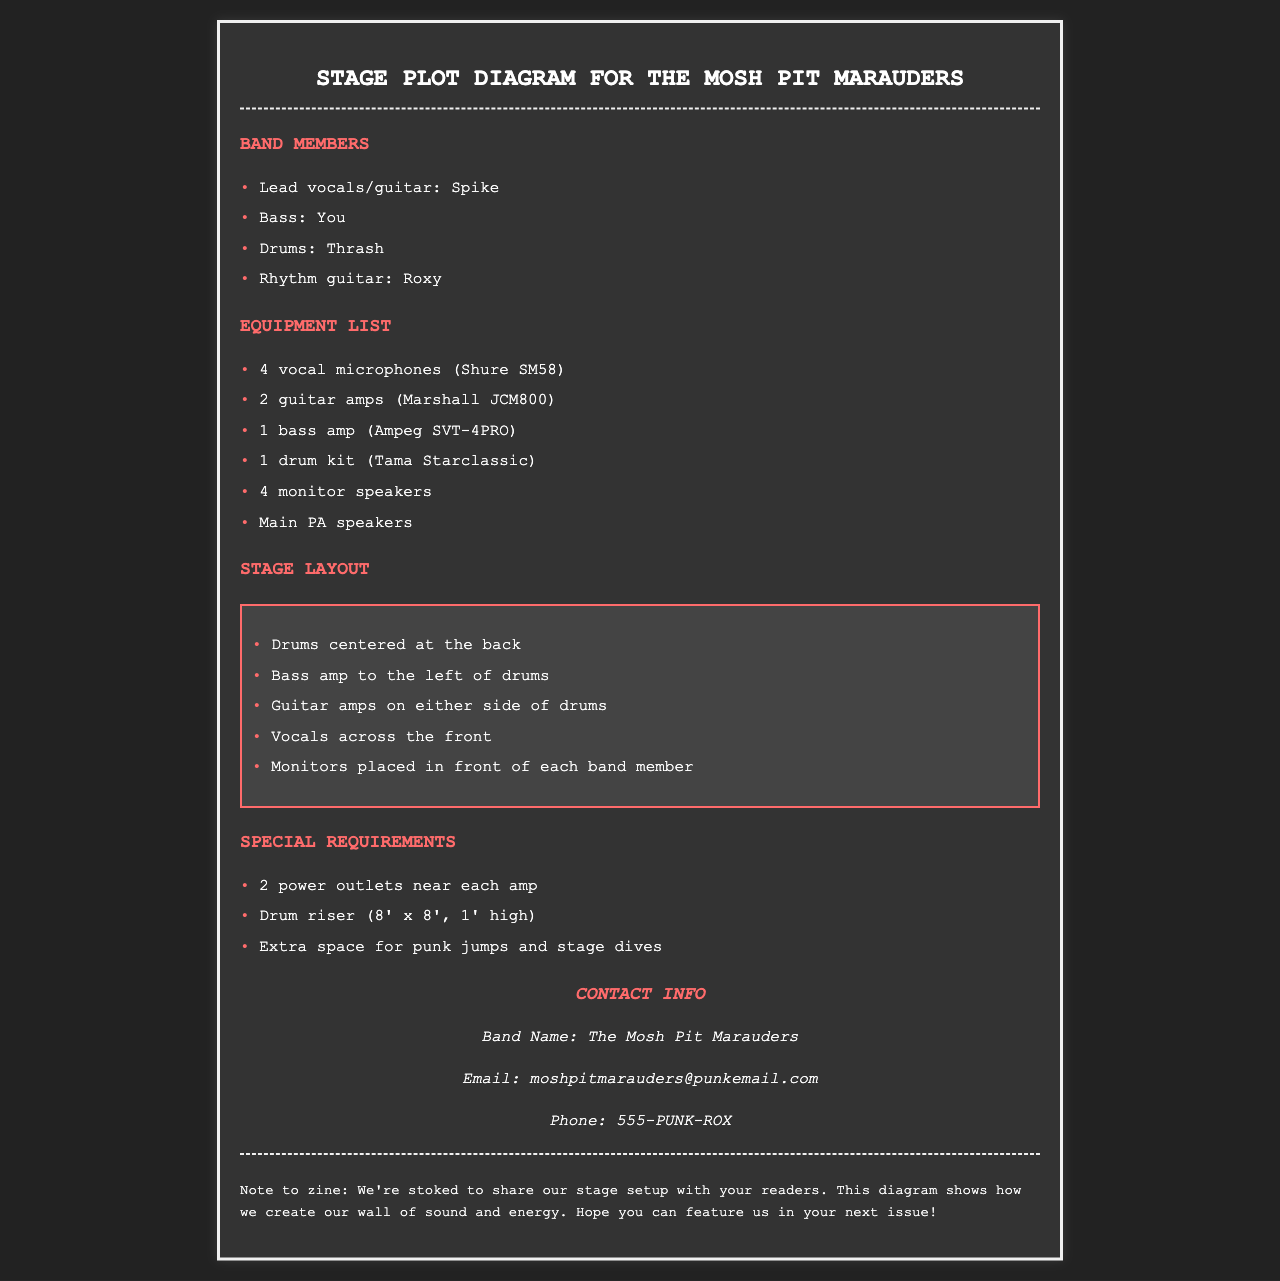what is the name of the band? The band is referred to as "The Mosh Pit Marauders" in the document title and in the contact info section.
Answer: The Mosh Pit Marauders who plays bass in the band? The bass guitarist is referred to as "You" in the list of band members.
Answer: You how many vocal microphones are listed? The equipment list specifies "4 vocal microphones" in the band setup.
Answer: 4 where is the bass amp located? The stage layout specifies that the bass amp is "to the left of drums."
Answer: left of drums what are the dimensions of the drum riser? The special requirements section states that the drum riser is "8' x 8', 1' high."
Answer: 8' x 8', 1' high how many guitar amps are mentioned in the equipment list? The equipment list includes "2 guitar amps" for the setup.
Answer: 2 what is included in the contact info? The contact info provides the band name, email, and phone number for booking or questions.
Answer: Band Name, Email, Phone what does the note to the zine express? The note conveys the band's excitement about sharing their stage setup and hopes for a feature in the zine.
Answer: excitement to share stage setup 